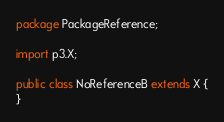<code> <loc_0><loc_0><loc_500><loc_500><_Java_>package PackageReference;

import p3.X;

public class NoReferenceB extends X {
}
</code> 